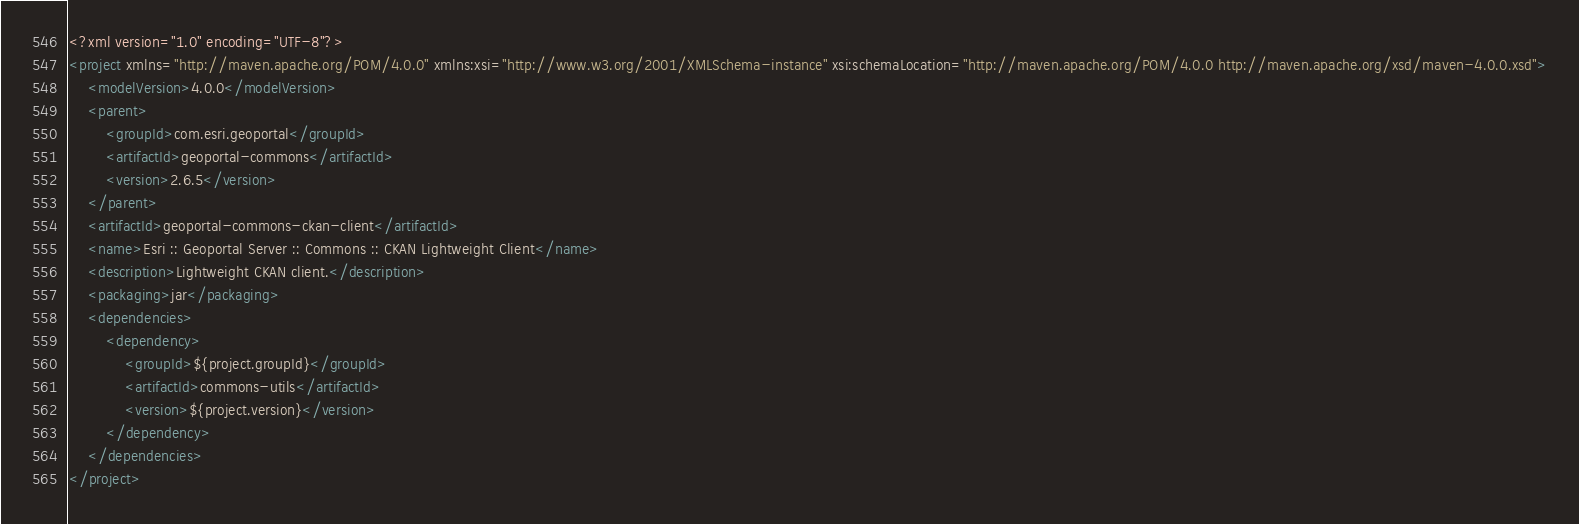Convert code to text. <code><loc_0><loc_0><loc_500><loc_500><_XML_><?xml version="1.0" encoding="UTF-8"?>
<project xmlns="http://maven.apache.org/POM/4.0.0" xmlns:xsi="http://www.w3.org/2001/XMLSchema-instance" xsi:schemaLocation="http://maven.apache.org/POM/4.0.0 http://maven.apache.org/xsd/maven-4.0.0.xsd">
    <modelVersion>4.0.0</modelVersion>
    <parent>
        <groupId>com.esri.geoportal</groupId>
        <artifactId>geoportal-commons</artifactId>
        <version>2.6.5</version>
    </parent>
    <artifactId>geoportal-commons-ckan-client</artifactId>
    <name>Esri :: Geoportal Server :: Commons :: CKAN Lightweight Client</name>
    <description>Lightweight CKAN client.</description>
    <packaging>jar</packaging>
    <dependencies>
        <dependency>
            <groupId>${project.groupId}</groupId>
            <artifactId>commons-utils</artifactId>
            <version>${project.version}</version>
        </dependency>
    </dependencies>
</project></code> 